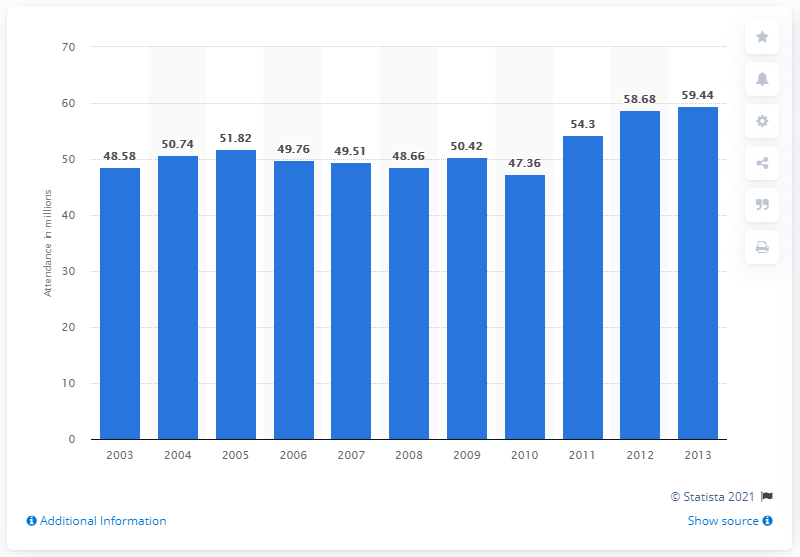Mention a couple of crucial points in this snapshot. In 2013, a popular music concert was attended by at least 59.44 people. 